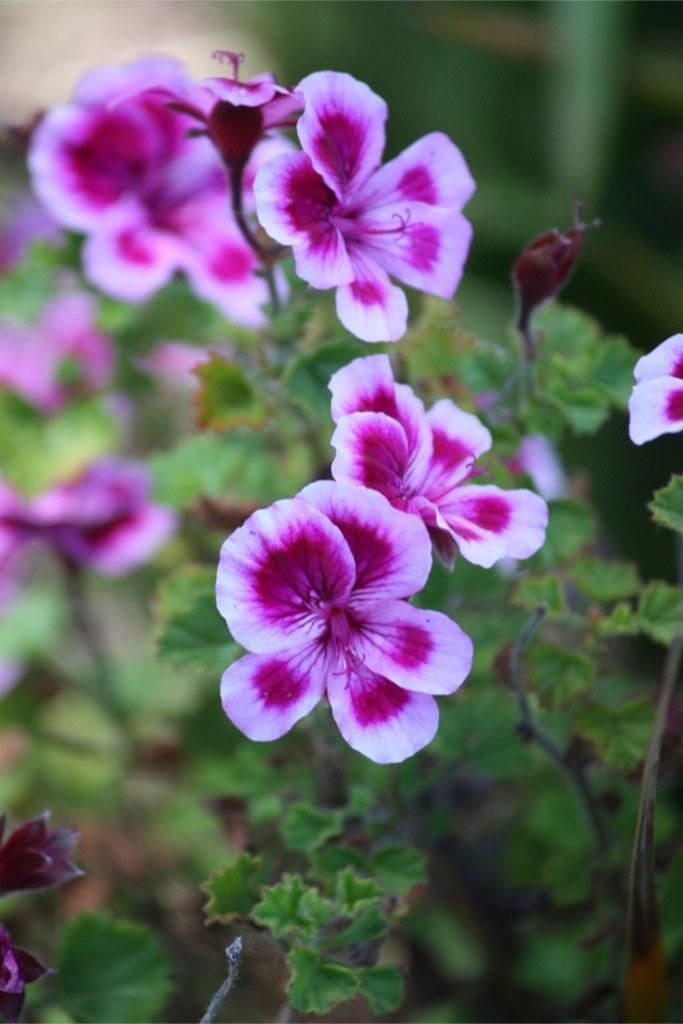Can you describe this image briefly? in this image I can see few flowers. They are in purple and white color. I can see a green color leaves. 